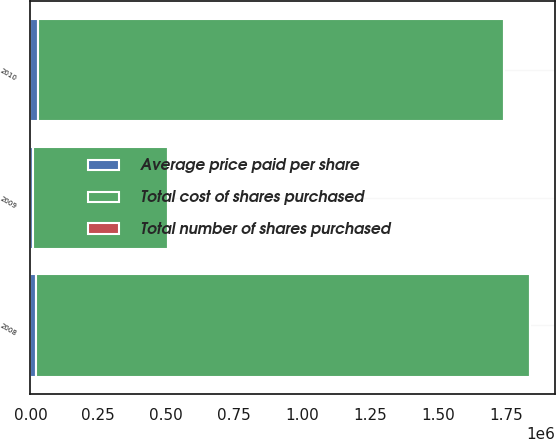Convert chart to OTSL. <chart><loc_0><loc_0><loc_500><loc_500><stacked_bar_chart><ecel><fcel>2010<fcel>2009<fcel>2008<nl><fcel>Total cost of shares purchased<fcel>1.71668e+06<fcel>500097<fcel>1.81884e+06<nl><fcel>Average price paid per share<fcel>26624.8<fcel>7825<fcel>21064.7<nl><fcel>Total number of shares purchased<fcel>64.48<fcel>63.91<fcel>86.35<nl></chart> 